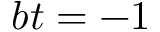<formula> <loc_0><loc_0><loc_500><loc_500>b t = - 1</formula> 